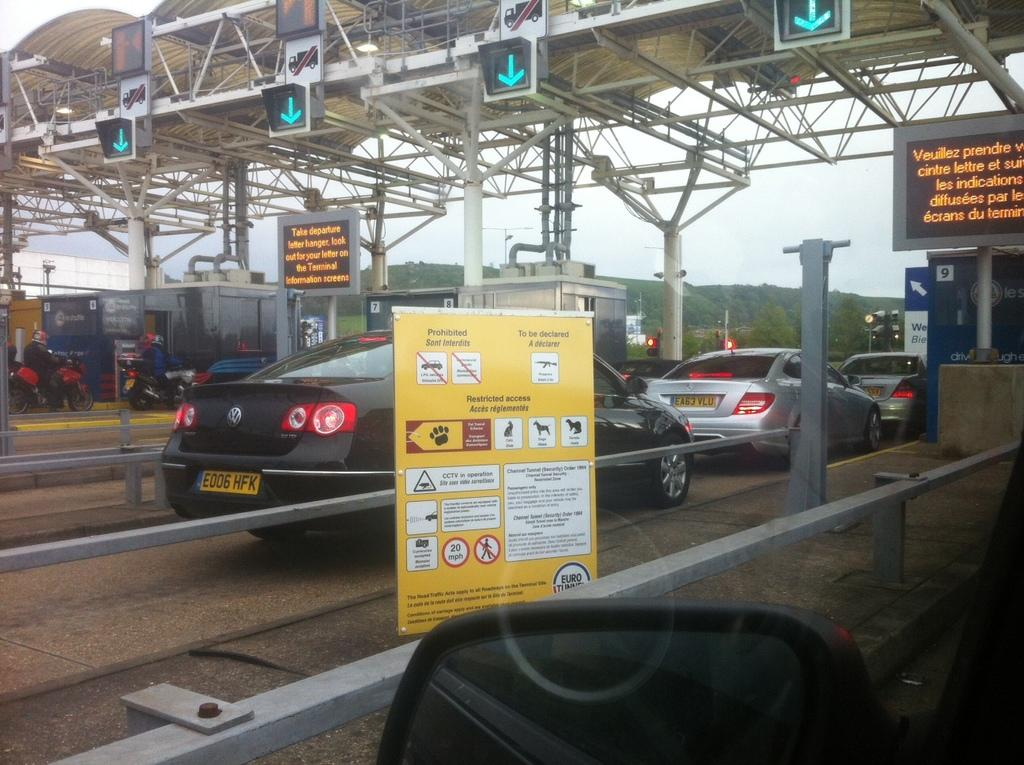<image>
Provide a brief description of the given image. a license plate with the letters HFK on it 